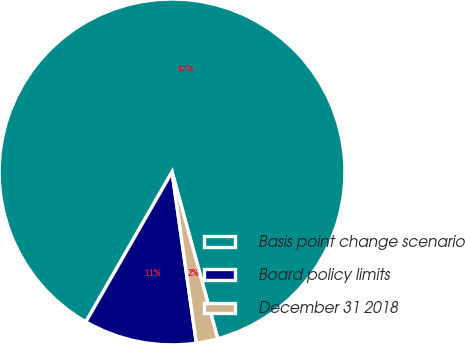Convert chart to OTSL. <chart><loc_0><loc_0><loc_500><loc_500><pie_chart><fcel>Basis point change scenario<fcel>Board policy limits<fcel>December 31 2018<nl><fcel>87.44%<fcel>10.55%<fcel>2.01%<nl></chart> 